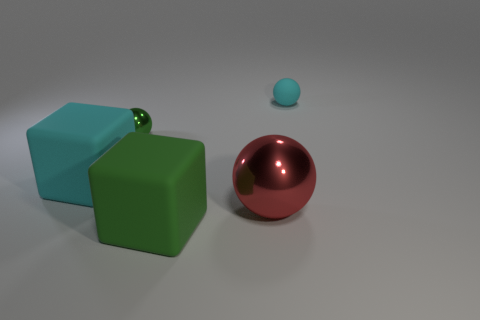Subtract all cyan matte spheres. How many spheres are left? 2 Subtract all yellow blocks. How many gray balls are left? 0 Add 3 green cubes. How many objects exist? 8 Subtract all red spheres. How many spheres are left? 2 Subtract 0 blue cylinders. How many objects are left? 5 Subtract all cubes. How many objects are left? 3 Subtract 2 balls. How many balls are left? 1 Subtract all brown spheres. Subtract all gray cubes. How many spheres are left? 3 Subtract all small cyan objects. Subtract all large green rubber things. How many objects are left? 3 Add 2 red objects. How many red objects are left? 3 